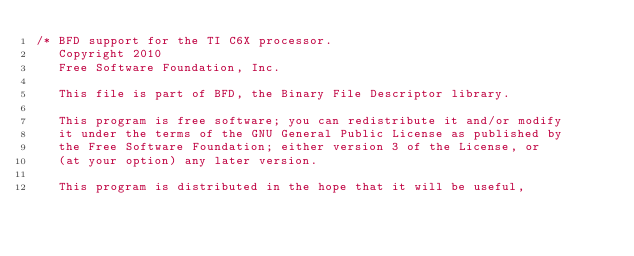Convert code to text. <code><loc_0><loc_0><loc_500><loc_500><_C_>/* BFD support for the TI C6X processor.
   Copyright 2010
   Free Software Foundation, Inc.

   This file is part of BFD, the Binary File Descriptor library.

   This program is free software; you can redistribute it and/or modify
   it under the terms of the GNU General Public License as published by
   the Free Software Foundation; either version 3 of the License, or
   (at your option) any later version.

   This program is distributed in the hope that it will be useful,</code> 